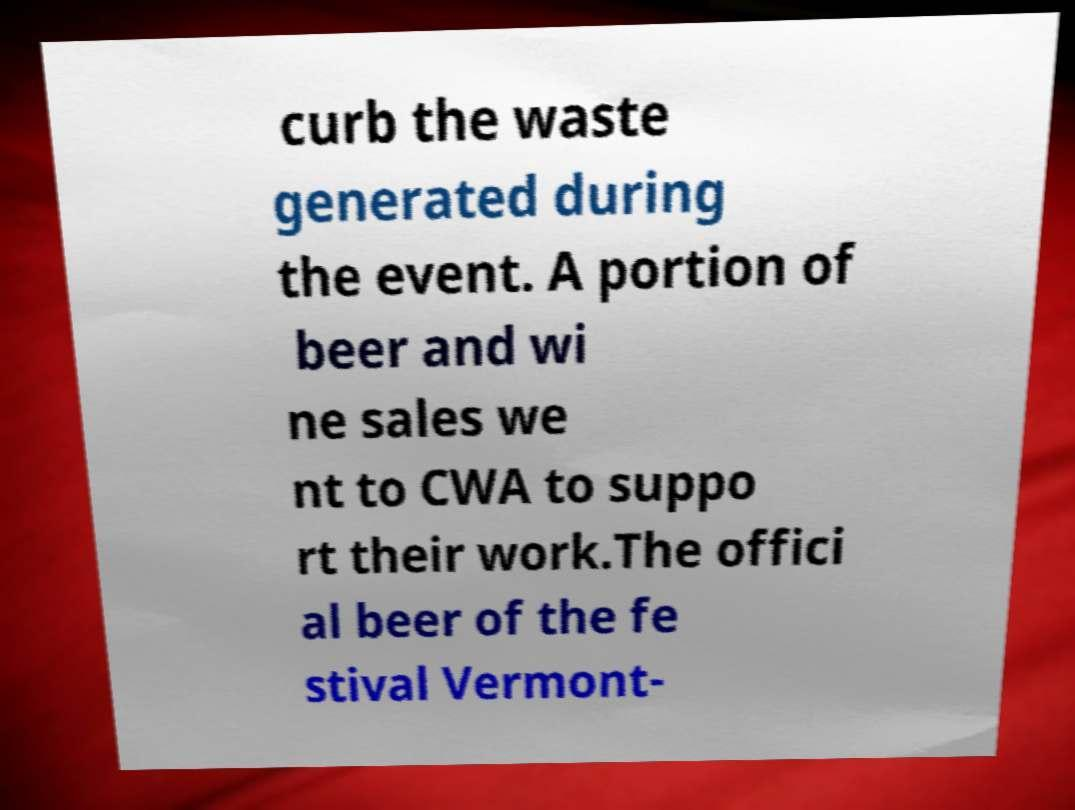There's text embedded in this image that I need extracted. Can you transcribe it verbatim? curb the waste generated during the event. A portion of beer and wi ne sales we nt to CWA to suppo rt their work.The offici al beer of the fe stival Vermont- 